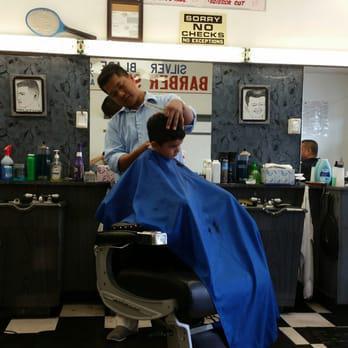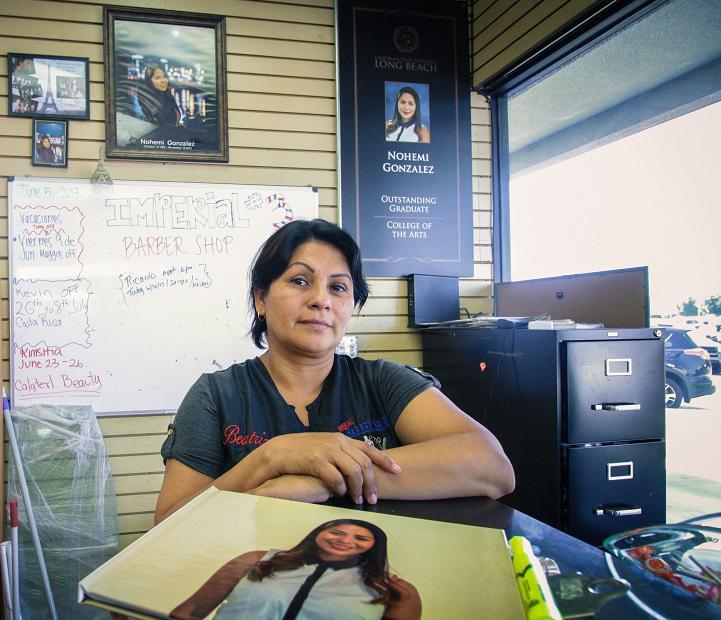The first image is the image on the left, the second image is the image on the right. For the images displayed, is the sentence "Foreground of an image shows a barber in blue by an adult male customer draped in blue." factually correct? Answer yes or no. No. The first image is the image on the left, the second image is the image on the right. Given the left and right images, does the statement "In the right image, there are two people looking straight ahead." hold true? Answer yes or no. No. 